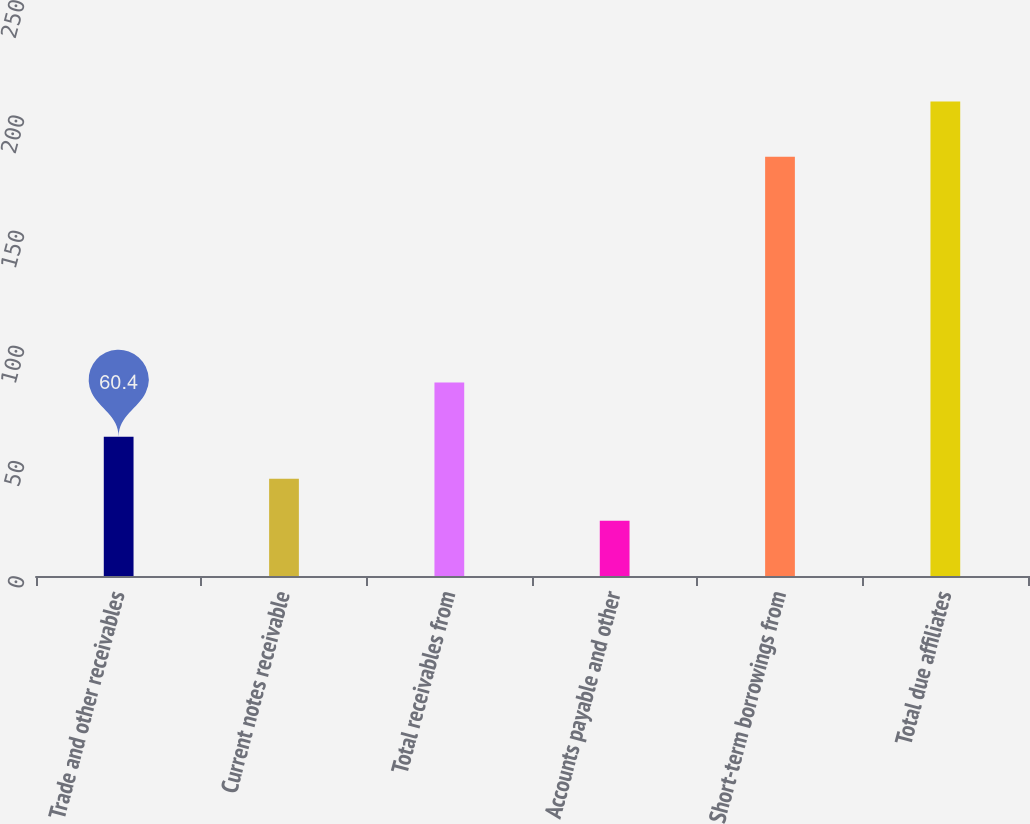<chart> <loc_0><loc_0><loc_500><loc_500><bar_chart><fcel>Trade and other receivables<fcel>Current notes receivable<fcel>Total receivables from<fcel>Accounts payable and other<fcel>Short-term borrowings from<fcel>Total due affiliates<nl><fcel>60.4<fcel>42.2<fcel>84<fcel>24<fcel>182<fcel>206<nl></chart> 